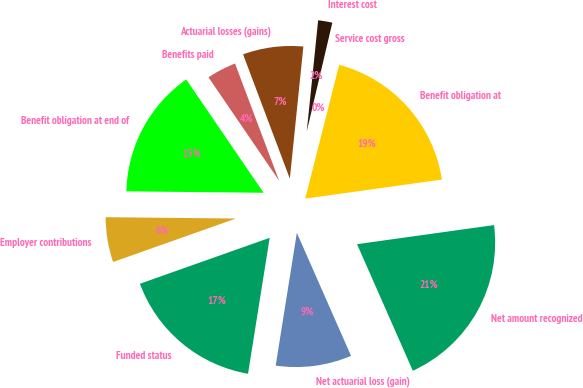Convert chart. <chart><loc_0><loc_0><loc_500><loc_500><pie_chart><fcel>Benefit obligation at<fcel>Service cost gross<fcel>Interest cost<fcel>Actuarial losses (gains)<fcel>Benefits paid<fcel>Benefit obligation at end of<fcel>Employer contributions<fcel>Funded status<fcel>Net actuarial loss (gain)<fcel>Net amount recognized<nl><fcel>18.84%<fcel>0.28%<fcel>2.05%<fcel>7.35%<fcel>3.81%<fcel>15.3%<fcel>5.58%<fcel>17.07%<fcel>9.12%<fcel>20.6%<nl></chart> 